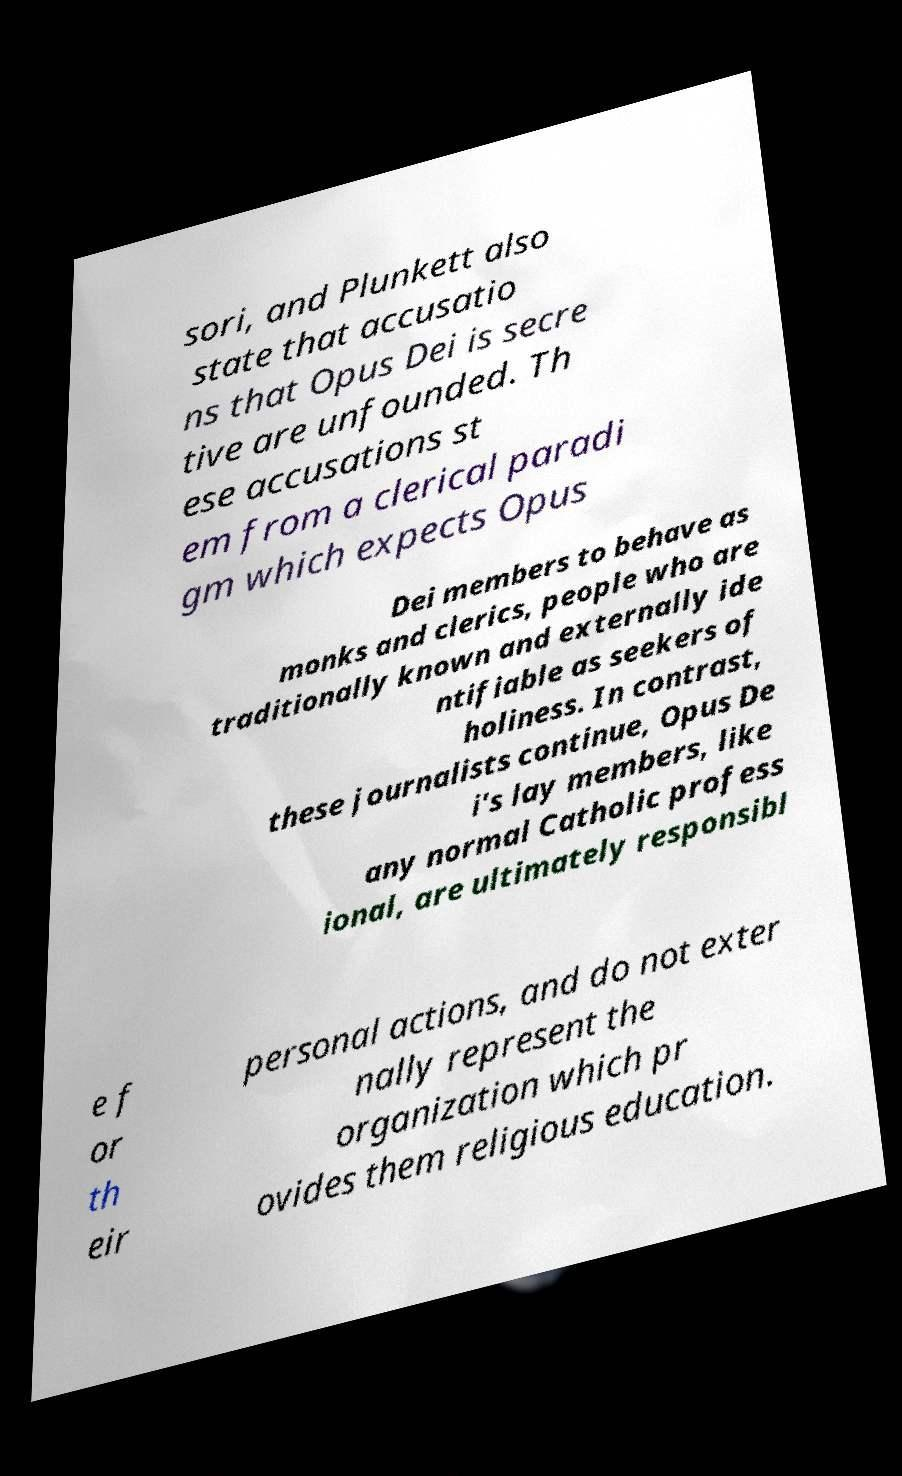Could you extract and type out the text from this image? sori, and Plunkett also state that accusatio ns that Opus Dei is secre tive are unfounded. Th ese accusations st em from a clerical paradi gm which expects Opus Dei members to behave as monks and clerics, people who are traditionally known and externally ide ntifiable as seekers of holiness. In contrast, these journalists continue, Opus De i's lay members, like any normal Catholic profess ional, are ultimately responsibl e f or th eir personal actions, and do not exter nally represent the organization which pr ovides them religious education. 